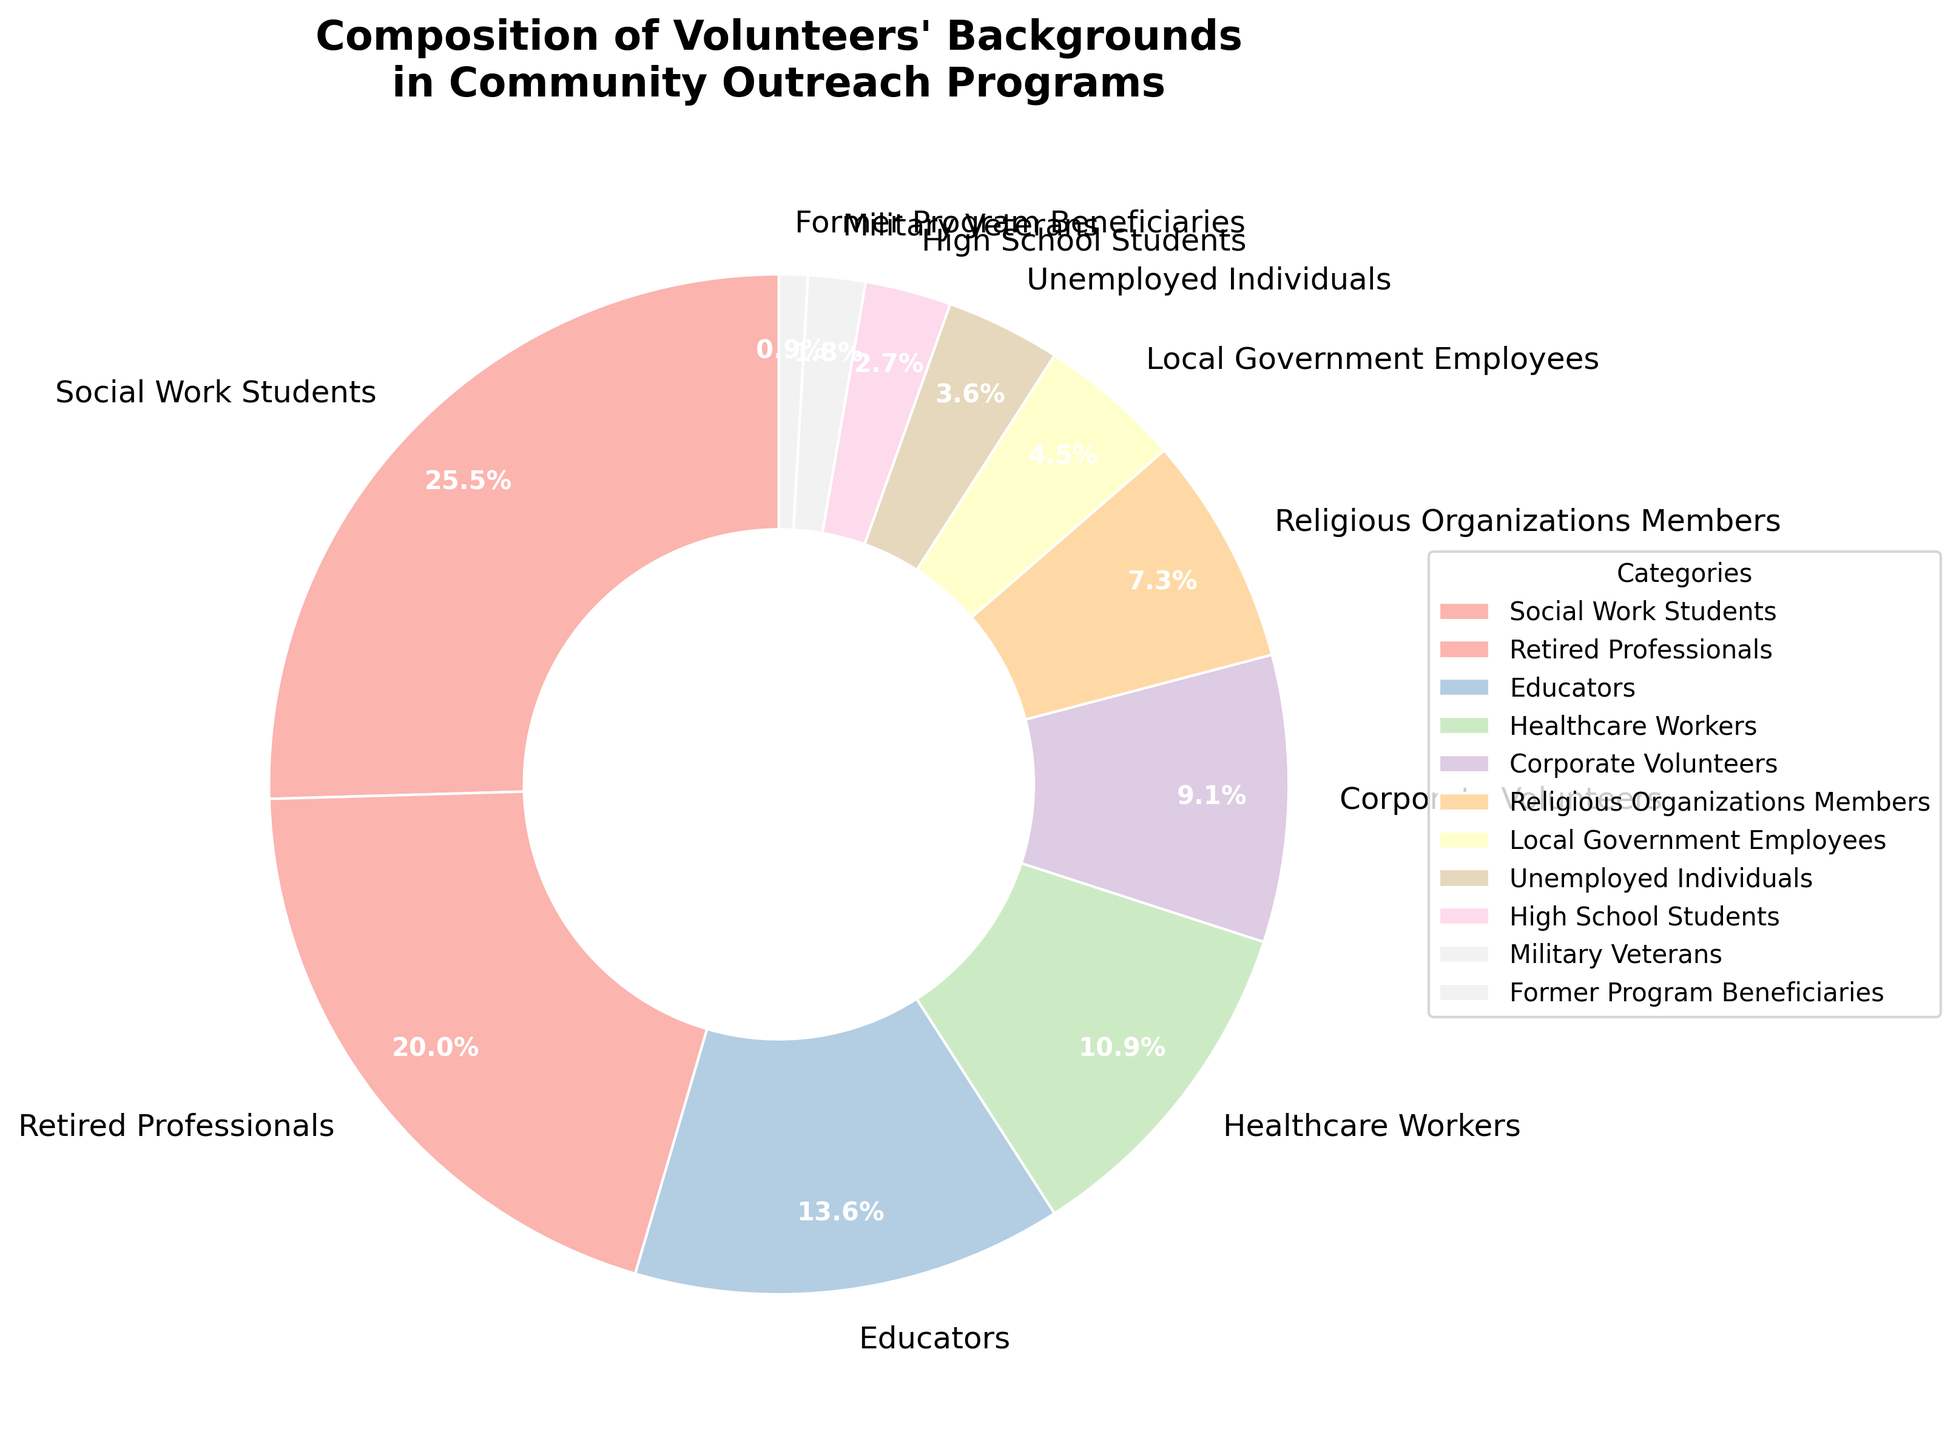Which category has the highest percentage of volunteers? To find the category with the highest percentage, look for the largest section in the pie chart. The label for the largest section indicates the category.
Answer: Social Work Students What is the total percentage of volunteers from both Educators and Healthcare Workers combined? Add the percentages of Educators and Healthcare Workers from the chart. Educators have 15% and Healthcare Workers have 12%. So, 15% + 12% = 27%.
Answer: 27% How does the percentage of Corporate Volunteers compare to the percentage of Retired Professionals? To compare, look at the sizes of the sections labeled Corporate Volunteers and Retired Professionals. Corporate Volunteers have 10%, whereas Retired Professionals have 22%. So, Retired Professionals have a higher percentage.
Answer: Retired Professionals have a higher percentage Which group comprises a smaller portion of volunteers, Military Veterans or Unemployed Individuals? Compare the labels for Military Veterans and Unemployed Individuals. Military Veterans stand at 2%, while Unemployed Individuals are at 4%.
Answer: Military Veterans What is the combined percentage of volunteers from categories each less than 5%? Identify the category each with less than 5%. Local Government Employees (5%), Unemployed Individuals (4%), High School Students (3%), Military Veterans (2%), and Former Program Beneficiaries (1%). Add these: 5% + 4% + 3% + 2% + 1% = 15%
Answer: 15% What is the difference in percentage between the highest and lowest categories? Subtract the percentage of the smallest category (Former Program Beneficiaries, 1%) from the largest category (Social Work Students, 28%). 28% - 1% = 27%
Answer: 27% Which color represents the Healthcare Workers category in the pie chart? Locate the section labeled Healthcare Workers in the chart and note the color used to fill that section.
Answer: Varies (requires visual observation) Estimate the median percentage value of all categories. Arrange the categories in ascending order by percentage: 1%, 2%, 3%, 4%, 5%, 8%, 10%, 12%, 15%, 22%, 28%. The median is the middle value, which corresponds to the 6th value in an 11-element list. Here the median is 8%.
Answer: 8% 